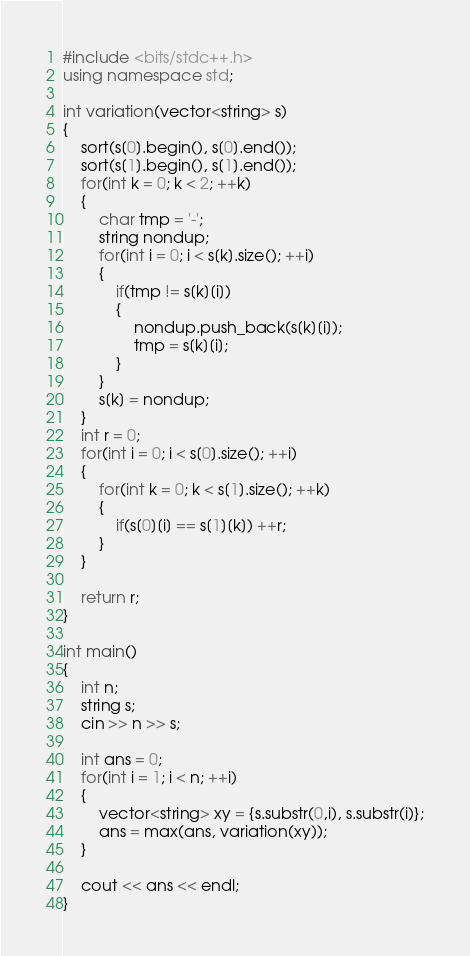Convert code to text. <code><loc_0><loc_0><loc_500><loc_500><_C++_>#include <bits/stdc++.h>
using namespace std;

int variation(vector<string> s)
{
    sort(s[0].begin(), s[0].end());
    sort(s[1].begin(), s[1].end());
    for(int k = 0; k < 2; ++k)
    {
        char tmp = '-';
        string nondup;
        for(int i = 0; i < s[k].size(); ++i)
        {
            if(tmp != s[k][i])
            {
                nondup.push_back(s[k][i]);
                tmp = s[k][i];
            }
        }
        s[k] = nondup;
    }
    int r = 0;
    for(int i = 0; i < s[0].size(); ++i)
    {
        for(int k = 0; k < s[1].size(); ++k)
        {
            if(s[0][i] == s[1][k]) ++r;
        }
    }

    return r;
}

int main()
{
    int n;
    string s;
    cin >> n >> s;
    
    int ans = 0;
    for(int i = 1; i < n; ++i)
    {
        vector<string> xy = {s.substr(0,i), s.substr(i)};
        ans = max(ans, variation(xy));
    }
    
    cout << ans << endl;
}</code> 